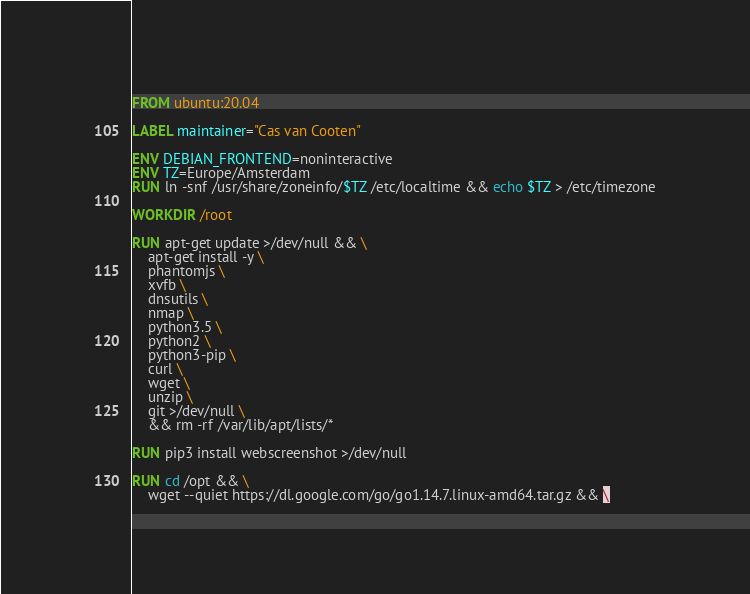Convert code to text. <code><loc_0><loc_0><loc_500><loc_500><_Dockerfile_>FROM ubuntu:20.04

LABEL maintainer="Cas van Cooten"

ENV DEBIAN_FRONTEND=noninteractive
ENV TZ=Europe/Amsterdam
RUN ln -snf /usr/share/zoneinfo/$TZ /etc/localtime && echo $TZ > /etc/timezone

WORKDIR /root

RUN apt-get update >/dev/null && \
    apt-get install -y \
    phantomjs \
    xvfb \
    dnsutils \
    nmap \
    python3.5 \
    python2 \
    python3-pip \
    curl \
    wget \
    unzip \
    git >/dev/null \
    && rm -rf /var/lib/apt/lists/*

RUN pip3 install webscreenshot >/dev/null

RUN cd /opt && \
    wget --quiet https://dl.google.com/go/go1.14.7.linux-amd64.tar.gz && \</code> 